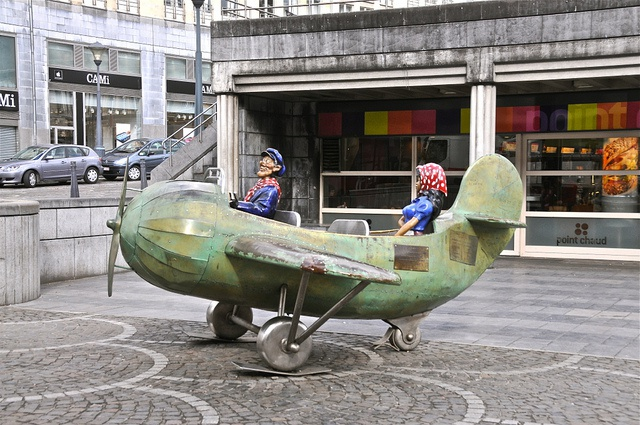Describe the objects in this image and their specific colors. I can see airplane in lavender, darkgray, black, gray, and lightgray tones, car in lavender, gray, darkgray, and black tones, people in lavender, black, navy, blue, and gray tones, people in lavender, white, gray, lightblue, and lightpink tones, and car in lavender, gray, darkgray, and black tones in this image. 